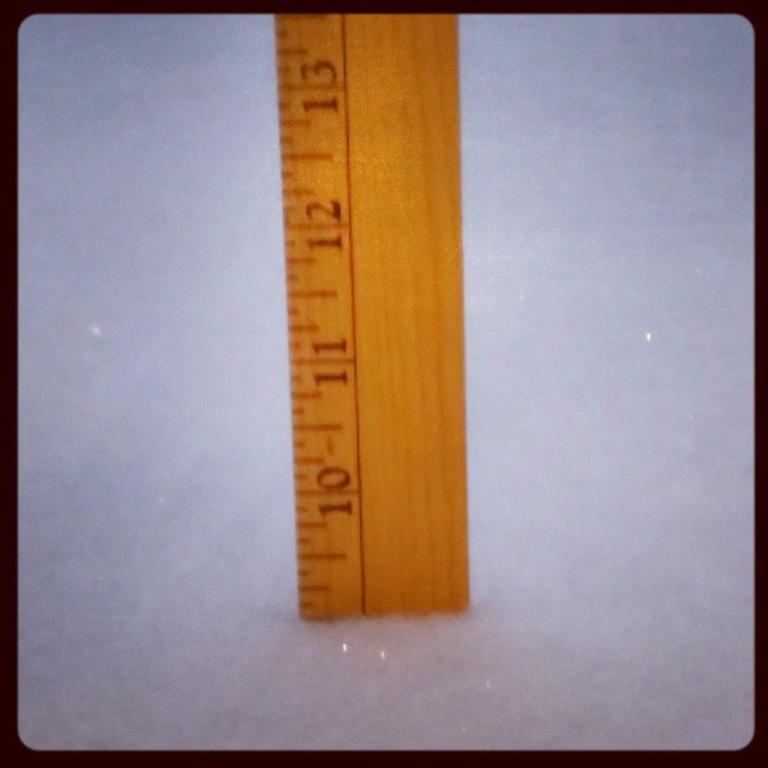<image>
Render a clear and concise summary of the photo. A wooden ruled placed in a snow bank with the numbers 10 through 13 visible. 